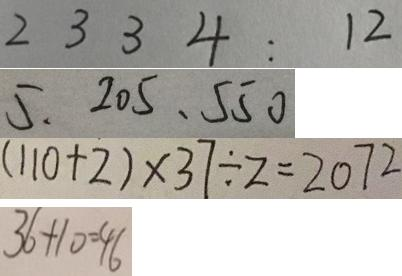<formula> <loc_0><loc_0><loc_500><loc_500>2 3 3 4 : 1 2 
 5 . 2 0 5 、 5 5 0 
 ( 1 1 0 + 2 ) \times 3 7 \div 2 = 2 0 7 2 
 3 6 + 1 0 = 4 6</formula> 